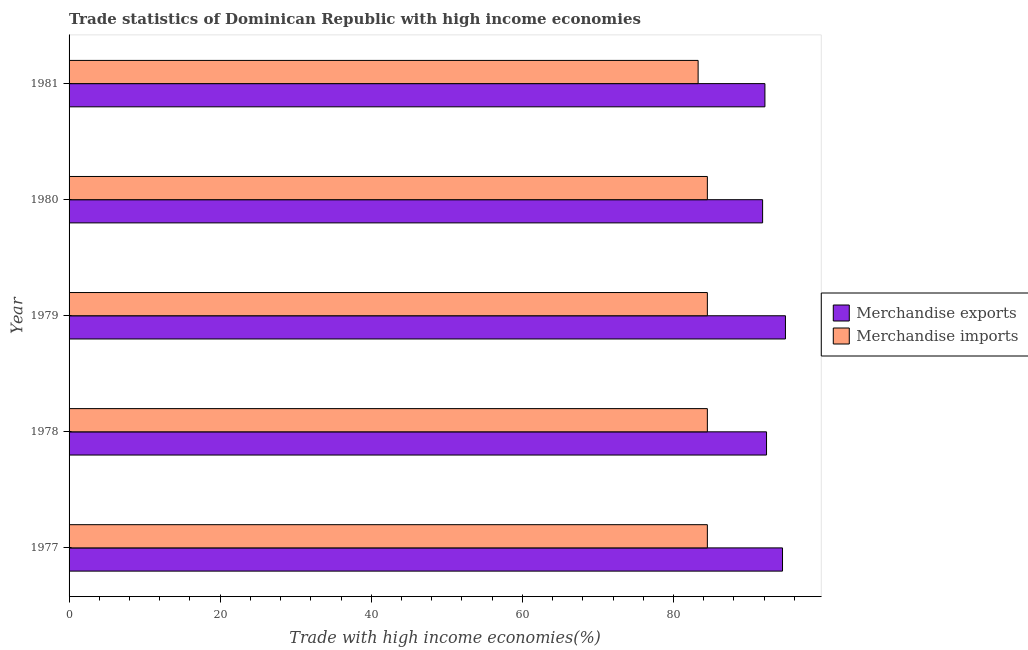How many groups of bars are there?
Offer a very short reply. 5. What is the label of the 4th group of bars from the top?
Ensure brevity in your answer.  1978. In how many cases, is the number of bars for a given year not equal to the number of legend labels?
Offer a terse response. 0. What is the merchandise imports in 1978?
Make the answer very short. 84.48. Across all years, what is the maximum merchandise exports?
Your response must be concise. 94.82. Across all years, what is the minimum merchandise exports?
Give a very brief answer. 91.79. In which year was the merchandise imports maximum?
Your answer should be compact. 1978. What is the total merchandise exports in the graph?
Your response must be concise. 465.44. What is the difference between the merchandise exports in 1977 and that in 1979?
Keep it short and to the point. -0.39. What is the difference between the merchandise exports in 1977 and the merchandise imports in 1980?
Give a very brief answer. 9.95. What is the average merchandise exports per year?
Ensure brevity in your answer.  93.09. In the year 1977, what is the difference between the merchandise imports and merchandise exports?
Offer a very short reply. -9.95. Is the merchandise exports in 1977 less than that in 1979?
Your answer should be compact. Yes. What is the difference between the highest and the lowest merchandise imports?
Make the answer very short. 1.22. In how many years, is the merchandise imports greater than the average merchandise imports taken over all years?
Provide a succinct answer. 4. Is the sum of the merchandise imports in 1978 and 1980 greater than the maximum merchandise exports across all years?
Provide a succinct answer. Yes. What does the 1st bar from the top in 1977 represents?
Make the answer very short. Merchandise imports. What does the 1st bar from the bottom in 1979 represents?
Provide a short and direct response. Merchandise exports. How many bars are there?
Provide a succinct answer. 10. Are all the bars in the graph horizontal?
Offer a terse response. Yes. Does the graph contain any zero values?
Offer a very short reply. No. Where does the legend appear in the graph?
Your response must be concise. Center right. How many legend labels are there?
Offer a terse response. 2. What is the title of the graph?
Offer a very short reply. Trade statistics of Dominican Republic with high income economies. What is the label or title of the X-axis?
Your answer should be compact. Trade with high income economies(%). What is the label or title of the Y-axis?
Ensure brevity in your answer.  Year. What is the Trade with high income economies(%) in Merchandise exports in 1977?
Your response must be concise. 94.43. What is the Trade with high income economies(%) in Merchandise imports in 1977?
Make the answer very short. 84.48. What is the Trade with high income economies(%) of Merchandise exports in 1978?
Make the answer very short. 92.31. What is the Trade with high income economies(%) of Merchandise imports in 1978?
Provide a succinct answer. 84.48. What is the Trade with high income economies(%) of Merchandise exports in 1979?
Offer a terse response. 94.82. What is the Trade with high income economies(%) of Merchandise imports in 1979?
Your response must be concise. 84.48. What is the Trade with high income economies(%) in Merchandise exports in 1980?
Give a very brief answer. 91.79. What is the Trade with high income economies(%) in Merchandise imports in 1980?
Make the answer very short. 84.48. What is the Trade with high income economies(%) of Merchandise exports in 1981?
Offer a terse response. 92.1. What is the Trade with high income economies(%) of Merchandise imports in 1981?
Your answer should be compact. 83.26. Across all years, what is the maximum Trade with high income economies(%) in Merchandise exports?
Keep it short and to the point. 94.82. Across all years, what is the maximum Trade with high income economies(%) of Merchandise imports?
Ensure brevity in your answer.  84.48. Across all years, what is the minimum Trade with high income economies(%) of Merchandise exports?
Provide a short and direct response. 91.79. Across all years, what is the minimum Trade with high income economies(%) in Merchandise imports?
Keep it short and to the point. 83.26. What is the total Trade with high income economies(%) of Merchandise exports in the graph?
Make the answer very short. 465.44. What is the total Trade with high income economies(%) in Merchandise imports in the graph?
Give a very brief answer. 421.17. What is the difference between the Trade with high income economies(%) in Merchandise exports in 1977 and that in 1978?
Provide a short and direct response. 2.12. What is the difference between the Trade with high income economies(%) of Merchandise imports in 1977 and that in 1978?
Keep it short and to the point. -0. What is the difference between the Trade with high income economies(%) of Merchandise exports in 1977 and that in 1979?
Provide a short and direct response. -0.39. What is the difference between the Trade with high income economies(%) of Merchandise exports in 1977 and that in 1980?
Offer a terse response. 2.64. What is the difference between the Trade with high income economies(%) in Merchandise exports in 1977 and that in 1981?
Provide a short and direct response. 2.33. What is the difference between the Trade with high income economies(%) of Merchandise imports in 1977 and that in 1981?
Your response must be concise. 1.22. What is the difference between the Trade with high income economies(%) in Merchandise exports in 1978 and that in 1979?
Provide a succinct answer. -2.5. What is the difference between the Trade with high income economies(%) in Merchandise imports in 1978 and that in 1979?
Your response must be concise. 0. What is the difference between the Trade with high income economies(%) of Merchandise exports in 1978 and that in 1980?
Your answer should be compact. 0.52. What is the difference between the Trade with high income economies(%) of Merchandise exports in 1978 and that in 1981?
Your response must be concise. 0.21. What is the difference between the Trade with high income economies(%) of Merchandise imports in 1978 and that in 1981?
Provide a succinct answer. 1.22. What is the difference between the Trade with high income economies(%) of Merchandise exports in 1979 and that in 1980?
Give a very brief answer. 3.02. What is the difference between the Trade with high income economies(%) in Merchandise imports in 1979 and that in 1980?
Make the answer very short. -0. What is the difference between the Trade with high income economies(%) of Merchandise exports in 1979 and that in 1981?
Give a very brief answer. 2.72. What is the difference between the Trade with high income economies(%) of Merchandise imports in 1979 and that in 1981?
Offer a terse response. 1.22. What is the difference between the Trade with high income economies(%) in Merchandise exports in 1980 and that in 1981?
Your answer should be very brief. -0.31. What is the difference between the Trade with high income economies(%) in Merchandise imports in 1980 and that in 1981?
Give a very brief answer. 1.22. What is the difference between the Trade with high income economies(%) in Merchandise exports in 1977 and the Trade with high income economies(%) in Merchandise imports in 1978?
Offer a terse response. 9.95. What is the difference between the Trade with high income economies(%) of Merchandise exports in 1977 and the Trade with high income economies(%) of Merchandise imports in 1979?
Your response must be concise. 9.95. What is the difference between the Trade with high income economies(%) of Merchandise exports in 1977 and the Trade with high income economies(%) of Merchandise imports in 1980?
Make the answer very short. 9.95. What is the difference between the Trade with high income economies(%) in Merchandise exports in 1977 and the Trade with high income economies(%) in Merchandise imports in 1981?
Give a very brief answer. 11.17. What is the difference between the Trade with high income economies(%) in Merchandise exports in 1978 and the Trade with high income economies(%) in Merchandise imports in 1979?
Ensure brevity in your answer.  7.83. What is the difference between the Trade with high income economies(%) of Merchandise exports in 1978 and the Trade with high income economies(%) of Merchandise imports in 1980?
Keep it short and to the point. 7.83. What is the difference between the Trade with high income economies(%) in Merchandise exports in 1978 and the Trade with high income economies(%) in Merchandise imports in 1981?
Your answer should be compact. 9.05. What is the difference between the Trade with high income economies(%) of Merchandise exports in 1979 and the Trade with high income economies(%) of Merchandise imports in 1980?
Give a very brief answer. 10.34. What is the difference between the Trade with high income economies(%) of Merchandise exports in 1979 and the Trade with high income economies(%) of Merchandise imports in 1981?
Provide a short and direct response. 11.56. What is the difference between the Trade with high income economies(%) in Merchandise exports in 1980 and the Trade with high income economies(%) in Merchandise imports in 1981?
Your answer should be very brief. 8.53. What is the average Trade with high income economies(%) in Merchandise exports per year?
Provide a succinct answer. 93.09. What is the average Trade with high income economies(%) of Merchandise imports per year?
Offer a terse response. 84.23. In the year 1977, what is the difference between the Trade with high income economies(%) in Merchandise exports and Trade with high income economies(%) in Merchandise imports?
Offer a terse response. 9.95. In the year 1978, what is the difference between the Trade with high income economies(%) in Merchandise exports and Trade with high income economies(%) in Merchandise imports?
Give a very brief answer. 7.83. In the year 1979, what is the difference between the Trade with high income economies(%) in Merchandise exports and Trade with high income economies(%) in Merchandise imports?
Your response must be concise. 10.34. In the year 1980, what is the difference between the Trade with high income economies(%) of Merchandise exports and Trade with high income economies(%) of Merchandise imports?
Make the answer very short. 7.31. In the year 1981, what is the difference between the Trade with high income economies(%) of Merchandise exports and Trade with high income economies(%) of Merchandise imports?
Offer a terse response. 8.84. What is the ratio of the Trade with high income economies(%) of Merchandise exports in 1977 to that in 1978?
Provide a succinct answer. 1.02. What is the ratio of the Trade with high income economies(%) of Merchandise exports in 1977 to that in 1979?
Make the answer very short. 1. What is the ratio of the Trade with high income economies(%) in Merchandise exports in 1977 to that in 1980?
Your answer should be compact. 1.03. What is the ratio of the Trade with high income economies(%) of Merchandise exports in 1977 to that in 1981?
Offer a terse response. 1.03. What is the ratio of the Trade with high income economies(%) in Merchandise imports in 1977 to that in 1981?
Provide a succinct answer. 1.01. What is the ratio of the Trade with high income economies(%) in Merchandise exports in 1978 to that in 1979?
Provide a succinct answer. 0.97. What is the ratio of the Trade with high income economies(%) of Merchandise imports in 1978 to that in 1979?
Your response must be concise. 1. What is the ratio of the Trade with high income economies(%) of Merchandise exports in 1978 to that in 1981?
Your answer should be very brief. 1. What is the ratio of the Trade with high income economies(%) of Merchandise imports in 1978 to that in 1981?
Your response must be concise. 1.01. What is the ratio of the Trade with high income economies(%) in Merchandise exports in 1979 to that in 1980?
Ensure brevity in your answer.  1.03. What is the ratio of the Trade with high income economies(%) in Merchandise exports in 1979 to that in 1981?
Keep it short and to the point. 1.03. What is the ratio of the Trade with high income economies(%) in Merchandise imports in 1979 to that in 1981?
Keep it short and to the point. 1.01. What is the ratio of the Trade with high income economies(%) of Merchandise exports in 1980 to that in 1981?
Make the answer very short. 1. What is the ratio of the Trade with high income economies(%) of Merchandise imports in 1980 to that in 1981?
Make the answer very short. 1.01. What is the difference between the highest and the second highest Trade with high income economies(%) of Merchandise exports?
Give a very brief answer. 0.39. What is the difference between the highest and the lowest Trade with high income economies(%) in Merchandise exports?
Your response must be concise. 3.02. What is the difference between the highest and the lowest Trade with high income economies(%) in Merchandise imports?
Provide a succinct answer. 1.22. 